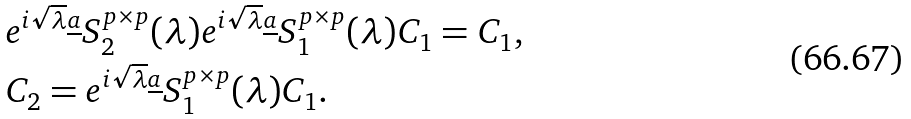<formula> <loc_0><loc_0><loc_500><loc_500>& e ^ { i \sqrt { \lambda } \underline { a } } S _ { 2 } ^ { p \times p } ( \lambda ) e ^ { i \sqrt { \lambda } \underline { a } } S _ { 1 } ^ { p \times p } ( \lambda ) C _ { 1 } = C _ { 1 } , \\ & C _ { 2 } = e ^ { i \sqrt { \lambda } \underline { a } } S _ { 1 } ^ { p \times p } ( \lambda ) C _ { 1 } .</formula> 